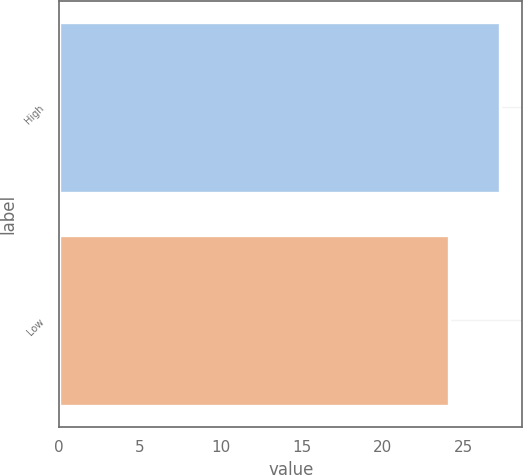Convert chart. <chart><loc_0><loc_0><loc_500><loc_500><bar_chart><fcel>High<fcel>Low<nl><fcel>27.29<fcel>24.13<nl></chart> 